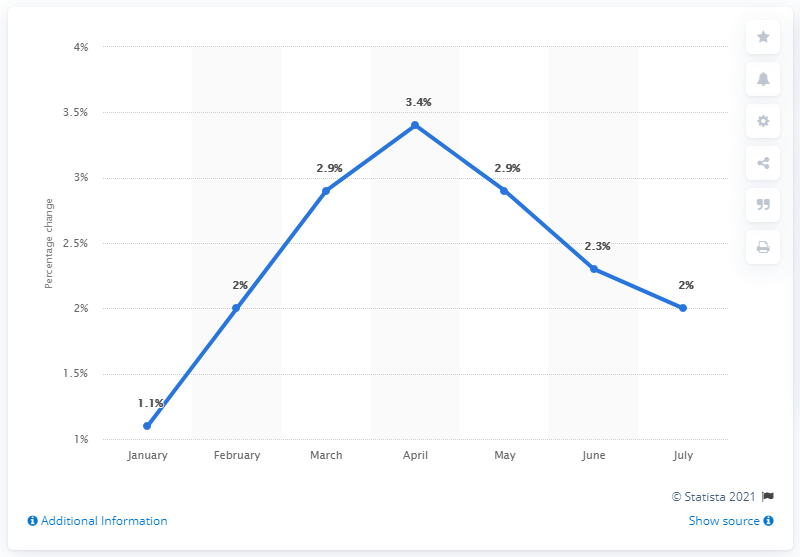Specify some key components in this picture. The price of steel aggregates increased by 1.1% between January 2011 and January 2012. 